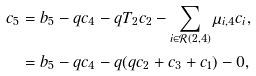Convert formula to latex. <formula><loc_0><loc_0><loc_500><loc_500>c _ { 5 } & = b _ { 5 } - q c _ { 4 } - q T _ { 2 } c _ { 2 } - \sum _ { i \in \mathcal { R } ( 2 , 4 ) } \mu _ { i , 4 } c _ { i } , \\ & = b _ { 5 } - q c _ { 4 } - q ( q c _ { 2 } + c _ { 3 } + c _ { 1 } ) - 0 ,</formula> 